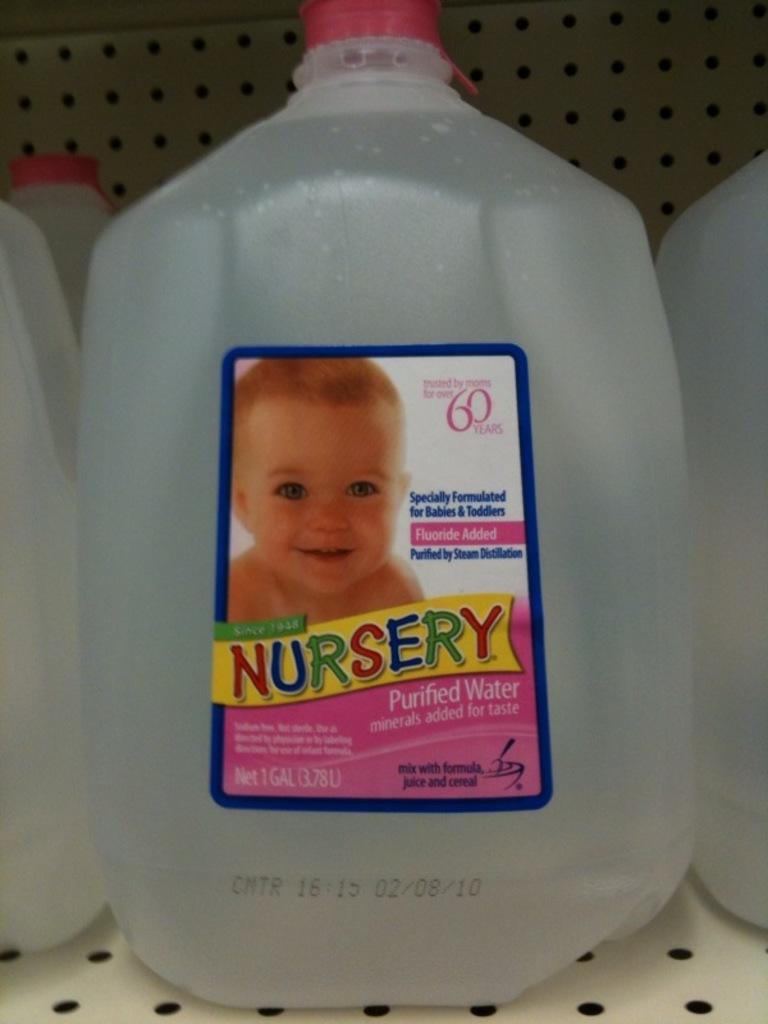Can you describe this image briefly? In this image i can see a sticker on the bottle, on the sticker there is a baby image, at the back ground i can see a iron wall. 